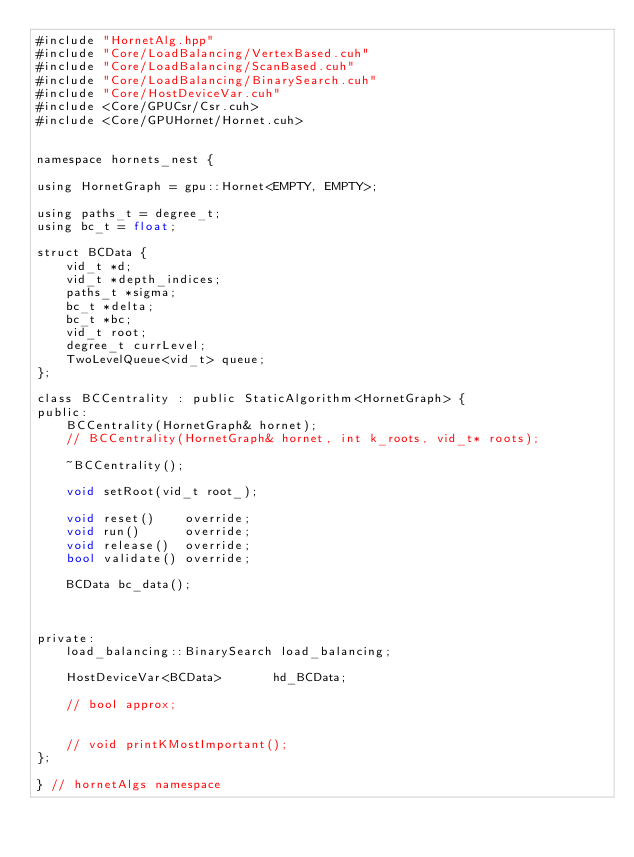<code> <loc_0><loc_0><loc_500><loc_500><_Cuda_>#include "HornetAlg.hpp"
#include "Core/LoadBalancing/VertexBased.cuh"
#include "Core/LoadBalancing/ScanBased.cuh"
#include "Core/LoadBalancing/BinarySearch.cuh"
#include "Core/HostDeviceVar.cuh"
#include <Core/GPUCsr/Csr.cuh>
#include <Core/GPUHornet/Hornet.cuh>


namespace hornets_nest {

using HornetGraph = gpu::Hornet<EMPTY, EMPTY>;

using paths_t = degree_t;
using bc_t = float;

struct BCData {
    vid_t *d;
    vid_t *depth_indices;
    paths_t *sigma;
    bc_t *delta;
    bc_t *bc;
    vid_t root;
    degree_t currLevel;
    TwoLevelQueue<vid_t> queue;
};

class BCCentrality : public StaticAlgorithm<HornetGraph> {
public:
    BCCentrality(HornetGraph& hornet);
    // BCCentrality(HornetGraph& hornet, int k_roots, vid_t* roots);

    ~BCCentrality();

    void setRoot(vid_t root_);

    void reset()    override;
    void run()      override;
    void release()  override;
    bool validate() override;

    BCData bc_data();



private:
    load_balancing::BinarySearch load_balancing;

    HostDeviceVar<BCData>       hd_BCData;    

    // bool approx;


    // void printKMostImportant();
};

} // hornetAlgs namespace
</code> 